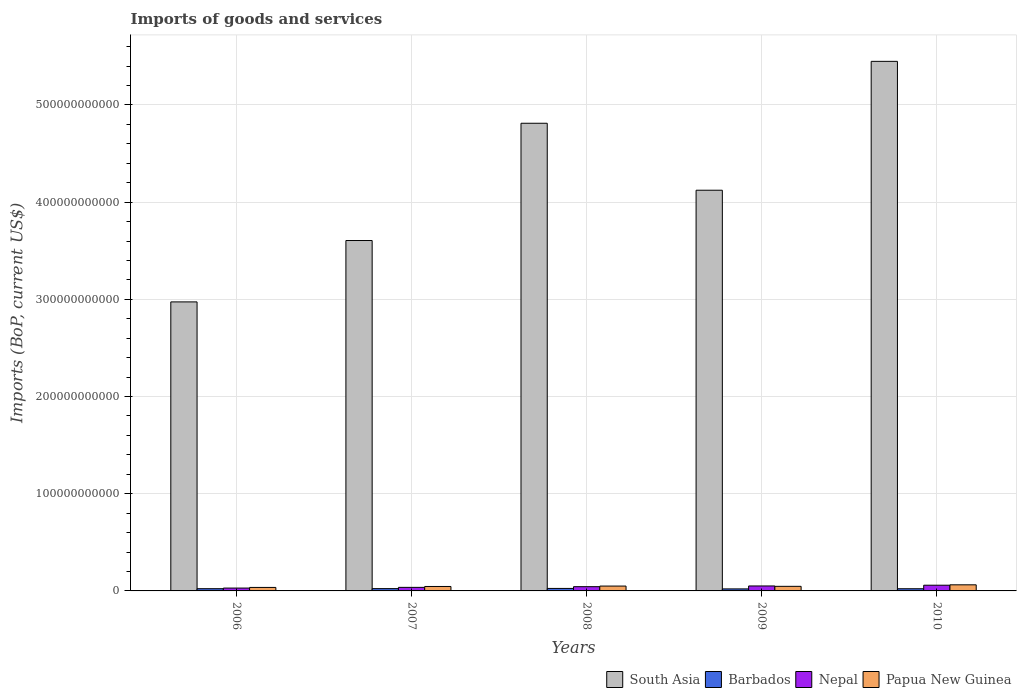How many different coloured bars are there?
Ensure brevity in your answer.  4. Are the number of bars per tick equal to the number of legend labels?
Keep it short and to the point. Yes. Are the number of bars on each tick of the X-axis equal?
Your response must be concise. Yes. How many bars are there on the 4th tick from the left?
Offer a very short reply. 4. How many bars are there on the 2nd tick from the right?
Your answer should be very brief. 4. What is the label of the 2nd group of bars from the left?
Offer a terse response. 2007. In how many cases, is the number of bars for a given year not equal to the number of legend labels?
Give a very brief answer. 0. What is the amount spent on imports in South Asia in 2007?
Your answer should be very brief. 3.61e+11. Across all years, what is the maximum amount spent on imports in Nepal?
Offer a terse response. 5.88e+09. Across all years, what is the minimum amount spent on imports in Barbados?
Offer a terse response. 2.08e+09. In which year was the amount spent on imports in South Asia maximum?
Make the answer very short. 2010. What is the total amount spent on imports in South Asia in the graph?
Make the answer very short. 2.10e+12. What is the difference between the amount spent on imports in Nepal in 2007 and that in 2008?
Make the answer very short. -7.16e+08. What is the difference between the amount spent on imports in South Asia in 2008 and the amount spent on imports in Nepal in 2006?
Provide a short and direct response. 4.78e+11. What is the average amount spent on imports in Papua New Guinea per year?
Ensure brevity in your answer.  4.83e+09. In the year 2006, what is the difference between the amount spent on imports in South Asia and amount spent on imports in Barbados?
Keep it short and to the point. 2.95e+11. In how many years, is the amount spent on imports in South Asia greater than 240000000000 US$?
Give a very brief answer. 5. What is the ratio of the amount spent on imports in Papua New Guinea in 2009 to that in 2010?
Your answer should be compact. 0.75. Is the amount spent on imports in Barbados in 2006 less than that in 2009?
Your response must be concise. No. What is the difference between the highest and the second highest amount spent on imports in South Asia?
Give a very brief answer. 6.37e+1. What is the difference between the highest and the lowest amount spent on imports in Papua New Guinea?
Give a very brief answer. 2.70e+09. In how many years, is the amount spent on imports in Papua New Guinea greater than the average amount spent on imports in Papua New Guinea taken over all years?
Your answer should be compact. 2. Is the sum of the amount spent on imports in Barbados in 2008 and 2010 greater than the maximum amount spent on imports in Papua New Guinea across all years?
Provide a succinct answer. No. Is it the case that in every year, the sum of the amount spent on imports in Papua New Guinea and amount spent on imports in South Asia is greater than the sum of amount spent on imports in Barbados and amount spent on imports in Nepal?
Ensure brevity in your answer.  Yes. What does the 2nd bar from the left in 2007 represents?
Keep it short and to the point. Barbados. What does the 3rd bar from the right in 2006 represents?
Keep it short and to the point. Barbados. Is it the case that in every year, the sum of the amount spent on imports in Papua New Guinea and amount spent on imports in Barbados is greater than the amount spent on imports in South Asia?
Provide a short and direct response. No. Are all the bars in the graph horizontal?
Your answer should be very brief. No. How many years are there in the graph?
Your answer should be very brief. 5. What is the difference between two consecutive major ticks on the Y-axis?
Provide a succinct answer. 1.00e+11. Does the graph contain grids?
Keep it short and to the point. Yes. Where does the legend appear in the graph?
Provide a succinct answer. Bottom right. How many legend labels are there?
Keep it short and to the point. 4. How are the legend labels stacked?
Make the answer very short. Horizontal. What is the title of the graph?
Give a very brief answer. Imports of goods and services. Does "Liechtenstein" appear as one of the legend labels in the graph?
Keep it short and to the point. No. What is the label or title of the Y-axis?
Your response must be concise. Imports (BoP, current US$). What is the Imports (BoP, current US$) of South Asia in 2006?
Your answer should be compact. 2.97e+11. What is the Imports (BoP, current US$) of Barbados in 2006?
Keep it short and to the point. 2.29e+09. What is the Imports (BoP, current US$) in Nepal in 2006?
Give a very brief answer. 2.93e+09. What is the Imports (BoP, current US$) in Papua New Guinea in 2006?
Your response must be concise. 3.59e+09. What is the Imports (BoP, current US$) in South Asia in 2007?
Provide a short and direct response. 3.61e+11. What is the Imports (BoP, current US$) of Barbados in 2007?
Keep it short and to the point. 2.37e+09. What is the Imports (BoP, current US$) of Nepal in 2007?
Offer a very short reply. 3.66e+09. What is the Imports (BoP, current US$) of Papua New Guinea in 2007?
Ensure brevity in your answer.  4.57e+09. What is the Imports (BoP, current US$) in South Asia in 2008?
Provide a succinct answer. 4.81e+11. What is the Imports (BoP, current US$) in Barbados in 2008?
Ensure brevity in your answer.  2.57e+09. What is the Imports (BoP, current US$) of Nepal in 2008?
Make the answer very short. 4.37e+09. What is the Imports (BoP, current US$) of Papua New Guinea in 2008?
Offer a terse response. 4.98e+09. What is the Imports (BoP, current US$) in South Asia in 2009?
Your answer should be very brief. 4.12e+11. What is the Imports (BoP, current US$) of Barbados in 2009?
Ensure brevity in your answer.  2.08e+09. What is the Imports (BoP, current US$) in Nepal in 2009?
Your answer should be compact. 5.10e+09. What is the Imports (BoP, current US$) in Papua New Guinea in 2009?
Offer a terse response. 4.71e+09. What is the Imports (BoP, current US$) of South Asia in 2010?
Offer a very short reply. 5.45e+11. What is the Imports (BoP, current US$) of Barbados in 2010?
Your answer should be compact. 2.24e+09. What is the Imports (BoP, current US$) of Nepal in 2010?
Give a very brief answer. 5.88e+09. What is the Imports (BoP, current US$) of Papua New Guinea in 2010?
Your response must be concise. 6.29e+09. Across all years, what is the maximum Imports (BoP, current US$) of South Asia?
Ensure brevity in your answer.  5.45e+11. Across all years, what is the maximum Imports (BoP, current US$) in Barbados?
Give a very brief answer. 2.57e+09. Across all years, what is the maximum Imports (BoP, current US$) in Nepal?
Make the answer very short. 5.88e+09. Across all years, what is the maximum Imports (BoP, current US$) of Papua New Guinea?
Provide a short and direct response. 6.29e+09. Across all years, what is the minimum Imports (BoP, current US$) of South Asia?
Ensure brevity in your answer.  2.97e+11. Across all years, what is the minimum Imports (BoP, current US$) of Barbados?
Offer a terse response. 2.08e+09. Across all years, what is the minimum Imports (BoP, current US$) in Nepal?
Ensure brevity in your answer.  2.93e+09. Across all years, what is the minimum Imports (BoP, current US$) in Papua New Guinea?
Provide a short and direct response. 3.59e+09. What is the total Imports (BoP, current US$) in South Asia in the graph?
Your response must be concise. 2.10e+12. What is the total Imports (BoP, current US$) in Barbados in the graph?
Ensure brevity in your answer.  1.15e+1. What is the total Imports (BoP, current US$) of Nepal in the graph?
Provide a succinct answer. 2.19e+1. What is the total Imports (BoP, current US$) in Papua New Guinea in the graph?
Ensure brevity in your answer.  2.41e+1. What is the difference between the Imports (BoP, current US$) in South Asia in 2006 and that in 2007?
Your answer should be very brief. -6.32e+1. What is the difference between the Imports (BoP, current US$) of Barbados in 2006 and that in 2007?
Provide a succinct answer. -7.39e+07. What is the difference between the Imports (BoP, current US$) of Nepal in 2006 and that in 2007?
Offer a terse response. -7.21e+08. What is the difference between the Imports (BoP, current US$) of Papua New Guinea in 2006 and that in 2007?
Provide a short and direct response. -9.88e+08. What is the difference between the Imports (BoP, current US$) of South Asia in 2006 and that in 2008?
Ensure brevity in your answer.  -1.84e+11. What is the difference between the Imports (BoP, current US$) of Barbados in 2006 and that in 2008?
Offer a terse response. -2.74e+08. What is the difference between the Imports (BoP, current US$) in Nepal in 2006 and that in 2008?
Provide a succinct answer. -1.44e+09. What is the difference between the Imports (BoP, current US$) of Papua New Guinea in 2006 and that in 2008?
Provide a succinct answer. -1.40e+09. What is the difference between the Imports (BoP, current US$) of South Asia in 2006 and that in 2009?
Offer a very short reply. -1.15e+11. What is the difference between the Imports (BoP, current US$) of Barbados in 2006 and that in 2009?
Give a very brief answer. 2.17e+08. What is the difference between the Imports (BoP, current US$) in Nepal in 2006 and that in 2009?
Give a very brief answer. -2.17e+09. What is the difference between the Imports (BoP, current US$) in Papua New Guinea in 2006 and that in 2009?
Provide a succinct answer. -1.12e+09. What is the difference between the Imports (BoP, current US$) in South Asia in 2006 and that in 2010?
Give a very brief answer. -2.48e+11. What is the difference between the Imports (BoP, current US$) in Barbados in 2006 and that in 2010?
Make the answer very short. 5.40e+07. What is the difference between the Imports (BoP, current US$) in Nepal in 2006 and that in 2010?
Offer a very short reply. -2.94e+09. What is the difference between the Imports (BoP, current US$) in Papua New Guinea in 2006 and that in 2010?
Offer a terse response. -2.70e+09. What is the difference between the Imports (BoP, current US$) in South Asia in 2007 and that in 2008?
Ensure brevity in your answer.  -1.21e+11. What is the difference between the Imports (BoP, current US$) of Barbados in 2007 and that in 2008?
Your response must be concise. -2.00e+08. What is the difference between the Imports (BoP, current US$) in Nepal in 2007 and that in 2008?
Provide a short and direct response. -7.16e+08. What is the difference between the Imports (BoP, current US$) in Papua New Guinea in 2007 and that in 2008?
Keep it short and to the point. -4.09e+08. What is the difference between the Imports (BoP, current US$) in South Asia in 2007 and that in 2009?
Make the answer very short. -5.18e+1. What is the difference between the Imports (BoP, current US$) in Barbados in 2007 and that in 2009?
Ensure brevity in your answer.  2.91e+08. What is the difference between the Imports (BoP, current US$) of Nepal in 2007 and that in 2009?
Provide a short and direct response. -1.45e+09. What is the difference between the Imports (BoP, current US$) in Papua New Guinea in 2007 and that in 2009?
Offer a terse response. -1.36e+08. What is the difference between the Imports (BoP, current US$) in South Asia in 2007 and that in 2010?
Provide a succinct answer. -1.84e+11. What is the difference between the Imports (BoP, current US$) in Barbados in 2007 and that in 2010?
Your response must be concise. 1.28e+08. What is the difference between the Imports (BoP, current US$) of Nepal in 2007 and that in 2010?
Your answer should be very brief. -2.22e+09. What is the difference between the Imports (BoP, current US$) of Papua New Guinea in 2007 and that in 2010?
Keep it short and to the point. -1.71e+09. What is the difference between the Imports (BoP, current US$) of South Asia in 2008 and that in 2009?
Ensure brevity in your answer.  6.89e+1. What is the difference between the Imports (BoP, current US$) in Barbados in 2008 and that in 2009?
Give a very brief answer. 4.92e+08. What is the difference between the Imports (BoP, current US$) in Nepal in 2008 and that in 2009?
Provide a short and direct response. -7.30e+08. What is the difference between the Imports (BoP, current US$) in Papua New Guinea in 2008 and that in 2009?
Provide a short and direct response. 2.73e+08. What is the difference between the Imports (BoP, current US$) in South Asia in 2008 and that in 2010?
Your answer should be compact. -6.37e+1. What is the difference between the Imports (BoP, current US$) of Barbados in 2008 and that in 2010?
Give a very brief answer. 3.28e+08. What is the difference between the Imports (BoP, current US$) in Nepal in 2008 and that in 2010?
Make the answer very short. -1.51e+09. What is the difference between the Imports (BoP, current US$) in Papua New Guinea in 2008 and that in 2010?
Provide a succinct answer. -1.30e+09. What is the difference between the Imports (BoP, current US$) in South Asia in 2009 and that in 2010?
Provide a succinct answer. -1.33e+11. What is the difference between the Imports (BoP, current US$) in Barbados in 2009 and that in 2010?
Your response must be concise. -1.63e+08. What is the difference between the Imports (BoP, current US$) of Nepal in 2009 and that in 2010?
Give a very brief answer. -7.78e+08. What is the difference between the Imports (BoP, current US$) in Papua New Guinea in 2009 and that in 2010?
Your response must be concise. -1.57e+09. What is the difference between the Imports (BoP, current US$) of South Asia in 2006 and the Imports (BoP, current US$) of Barbados in 2007?
Your response must be concise. 2.95e+11. What is the difference between the Imports (BoP, current US$) of South Asia in 2006 and the Imports (BoP, current US$) of Nepal in 2007?
Provide a short and direct response. 2.94e+11. What is the difference between the Imports (BoP, current US$) in South Asia in 2006 and the Imports (BoP, current US$) in Papua New Guinea in 2007?
Make the answer very short. 2.93e+11. What is the difference between the Imports (BoP, current US$) of Barbados in 2006 and the Imports (BoP, current US$) of Nepal in 2007?
Your answer should be very brief. -1.36e+09. What is the difference between the Imports (BoP, current US$) of Barbados in 2006 and the Imports (BoP, current US$) of Papua New Guinea in 2007?
Give a very brief answer. -2.28e+09. What is the difference between the Imports (BoP, current US$) in Nepal in 2006 and the Imports (BoP, current US$) in Papua New Guinea in 2007?
Your response must be concise. -1.64e+09. What is the difference between the Imports (BoP, current US$) in South Asia in 2006 and the Imports (BoP, current US$) in Barbados in 2008?
Ensure brevity in your answer.  2.95e+11. What is the difference between the Imports (BoP, current US$) in South Asia in 2006 and the Imports (BoP, current US$) in Nepal in 2008?
Your response must be concise. 2.93e+11. What is the difference between the Imports (BoP, current US$) of South Asia in 2006 and the Imports (BoP, current US$) of Papua New Guinea in 2008?
Give a very brief answer. 2.92e+11. What is the difference between the Imports (BoP, current US$) of Barbados in 2006 and the Imports (BoP, current US$) of Nepal in 2008?
Offer a very short reply. -2.08e+09. What is the difference between the Imports (BoP, current US$) of Barbados in 2006 and the Imports (BoP, current US$) of Papua New Guinea in 2008?
Provide a succinct answer. -2.69e+09. What is the difference between the Imports (BoP, current US$) of Nepal in 2006 and the Imports (BoP, current US$) of Papua New Guinea in 2008?
Your answer should be compact. -2.05e+09. What is the difference between the Imports (BoP, current US$) in South Asia in 2006 and the Imports (BoP, current US$) in Barbados in 2009?
Your answer should be very brief. 2.95e+11. What is the difference between the Imports (BoP, current US$) in South Asia in 2006 and the Imports (BoP, current US$) in Nepal in 2009?
Your response must be concise. 2.92e+11. What is the difference between the Imports (BoP, current US$) of South Asia in 2006 and the Imports (BoP, current US$) of Papua New Guinea in 2009?
Offer a terse response. 2.93e+11. What is the difference between the Imports (BoP, current US$) in Barbados in 2006 and the Imports (BoP, current US$) in Nepal in 2009?
Your response must be concise. -2.81e+09. What is the difference between the Imports (BoP, current US$) of Barbados in 2006 and the Imports (BoP, current US$) of Papua New Guinea in 2009?
Keep it short and to the point. -2.42e+09. What is the difference between the Imports (BoP, current US$) in Nepal in 2006 and the Imports (BoP, current US$) in Papua New Guinea in 2009?
Your response must be concise. -1.78e+09. What is the difference between the Imports (BoP, current US$) in South Asia in 2006 and the Imports (BoP, current US$) in Barbados in 2010?
Give a very brief answer. 2.95e+11. What is the difference between the Imports (BoP, current US$) of South Asia in 2006 and the Imports (BoP, current US$) of Nepal in 2010?
Provide a short and direct response. 2.92e+11. What is the difference between the Imports (BoP, current US$) of South Asia in 2006 and the Imports (BoP, current US$) of Papua New Guinea in 2010?
Your response must be concise. 2.91e+11. What is the difference between the Imports (BoP, current US$) of Barbados in 2006 and the Imports (BoP, current US$) of Nepal in 2010?
Your answer should be very brief. -3.58e+09. What is the difference between the Imports (BoP, current US$) of Barbados in 2006 and the Imports (BoP, current US$) of Papua New Guinea in 2010?
Your answer should be very brief. -3.99e+09. What is the difference between the Imports (BoP, current US$) of Nepal in 2006 and the Imports (BoP, current US$) of Papua New Guinea in 2010?
Provide a short and direct response. -3.35e+09. What is the difference between the Imports (BoP, current US$) of South Asia in 2007 and the Imports (BoP, current US$) of Barbados in 2008?
Make the answer very short. 3.58e+11. What is the difference between the Imports (BoP, current US$) in South Asia in 2007 and the Imports (BoP, current US$) in Nepal in 2008?
Your answer should be very brief. 3.56e+11. What is the difference between the Imports (BoP, current US$) of South Asia in 2007 and the Imports (BoP, current US$) of Papua New Guinea in 2008?
Make the answer very short. 3.56e+11. What is the difference between the Imports (BoP, current US$) in Barbados in 2007 and the Imports (BoP, current US$) in Nepal in 2008?
Make the answer very short. -2.00e+09. What is the difference between the Imports (BoP, current US$) of Barbados in 2007 and the Imports (BoP, current US$) of Papua New Guinea in 2008?
Provide a succinct answer. -2.62e+09. What is the difference between the Imports (BoP, current US$) in Nepal in 2007 and the Imports (BoP, current US$) in Papua New Guinea in 2008?
Make the answer very short. -1.33e+09. What is the difference between the Imports (BoP, current US$) in South Asia in 2007 and the Imports (BoP, current US$) in Barbados in 2009?
Keep it short and to the point. 3.58e+11. What is the difference between the Imports (BoP, current US$) in South Asia in 2007 and the Imports (BoP, current US$) in Nepal in 2009?
Your answer should be very brief. 3.55e+11. What is the difference between the Imports (BoP, current US$) in South Asia in 2007 and the Imports (BoP, current US$) in Papua New Guinea in 2009?
Offer a terse response. 3.56e+11. What is the difference between the Imports (BoP, current US$) in Barbados in 2007 and the Imports (BoP, current US$) in Nepal in 2009?
Provide a short and direct response. -2.73e+09. What is the difference between the Imports (BoP, current US$) in Barbados in 2007 and the Imports (BoP, current US$) in Papua New Guinea in 2009?
Provide a succinct answer. -2.34e+09. What is the difference between the Imports (BoP, current US$) of Nepal in 2007 and the Imports (BoP, current US$) of Papua New Guinea in 2009?
Offer a terse response. -1.06e+09. What is the difference between the Imports (BoP, current US$) of South Asia in 2007 and the Imports (BoP, current US$) of Barbados in 2010?
Give a very brief answer. 3.58e+11. What is the difference between the Imports (BoP, current US$) of South Asia in 2007 and the Imports (BoP, current US$) of Nepal in 2010?
Your answer should be compact. 3.55e+11. What is the difference between the Imports (BoP, current US$) in South Asia in 2007 and the Imports (BoP, current US$) in Papua New Guinea in 2010?
Offer a terse response. 3.54e+11. What is the difference between the Imports (BoP, current US$) in Barbados in 2007 and the Imports (BoP, current US$) in Nepal in 2010?
Make the answer very short. -3.51e+09. What is the difference between the Imports (BoP, current US$) of Barbados in 2007 and the Imports (BoP, current US$) of Papua New Guinea in 2010?
Keep it short and to the point. -3.92e+09. What is the difference between the Imports (BoP, current US$) in Nepal in 2007 and the Imports (BoP, current US$) in Papua New Guinea in 2010?
Offer a terse response. -2.63e+09. What is the difference between the Imports (BoP, current US$) in South Asia in 2008 and the Imports (BoP, current US$) in Barbados in 2009?
Offer a terse response. 4.79e+11. What is the difference between the Imports (BoP, current US$) in South Asia in 2008 and the Imports (BoP, current US$) in Nepal in 2009?
Give a very brief answer. 4.76e+11. What is the difference between the Imports (BoP, current US$) of South Asia in 2008 and the Imports (BoP, current US$) of Papua New Guinea in 2009?
Provide a succinct answer. 4.77e+11. What is the difference between the Imports (BoP, current US$) in Barbados in 2008 and the Imports (BoP, current US$) in Nepal in 2009?
Offer a terse response. -2.53e+09. What is the difference between the Imports (BoP, current US$) in Barbados in 2008 and the Imports (BoP, current US$) in Papua New Guinea in 2009?
Ensure brevity in your answer.  -2.14e+09. What is the difference between the Imports (BoP, current US$) in Nepal in 2008 and the Imports (BoP, current US$) in Papua New Guinea in 2009?
Offer a terse response. -3.40e+08. What is the difference between the Imports (BoP, current US$) of South Asia in 2008 and the Imports (BoP, current US$) of Barbados in 2010?
Make the answer very short. 4.79e+11. What is the difference between the Imports (BoP, current US$) in South Asia in 2008 and the Imports (BoP, current US$) in Nepal in 2010?
Your response must be concise. 4.75e+11. What is the difference between the Imports (BoP, current US$) in South Asia in 2008 and the Imports (BoP, current US$) in Papua New Guinea in 2010?
Offer a very short reply. 4.75e+11. What is the difference between the Imports (BoP, current US$) of Barbados in 2008 and the Imports (BoP, current US$) of Nepal in 2010?
Ensure brevity in your answer.  -3.31e+09. What is the difference between the Imports (BoP, current US$) in Barbados in 2008 and the Imports (BoP, current US$) in Papua New Guinea in 2010?
Offer a very short reply. -3.72e+09. What is the difference between the Imports (BoP, current US$) in Nepal in 2008 and the Imports (BoP, current US$) in Papua New Guinea in 2010?
Provide a short and direct response. -1.91e+09. What is the difference between the Imports (BoP, current US$) of South Asia in 2009 and the Imports (BoP, current US$) of Barbados in 2010?
Provide a succinct answer. 4.10e+11. What is the difference between the Imports (BoP, current US$) in South Asia in 2009 and the Imports (BoP, current US$) in Nepal in 2010?
Provide a succinct answer. 4.06e+11. What is the difference between the Imports (BoP, current US$) of South Asia in 2009 and the Imports (BoP, current US$) of Papua New Guinea in 2010?
Ensure brevity in your answer.  4.06e+11. What is the difference between the Imports (BoP, current US$) of Barbados in 2009 and the Imports (BoP, current US$) of Nepal in 2010?
Ensure brevity in your answer.  -3.80e+09. What is the difference between the Imports (BoP, current US$) in Barbados in 2009 and the Imports (BoP, current US$) in Papua New Guinea in 2010?
Your answer should be very brief. -4.21e+09. What is the difference between the Imports (BoP, current US$) in Nepal in 2009 and the Imports (BoP, current US$) in Papua New Guinea in 2010?
Your response must be concise. -1.18e+09. What is the average Imports (BoP, current US$) of South Asia per year?
Your answer should be very brief. 4.19e+11. What is the average Imports (BoP, current US$) in Barbados per year?
Your answer should be very brief. 2.31e+09. What is the average Imports (BoP, current US$) in Nepal per year?
Your response must be concise. 4.39e+09. What is the average Imports (BoP, current US$) of Papua New Guinea per year?
Provide a short and direct response. 4.83e+09. In the year 2006, what is the difference between the Imports (BoP, current US$) of South Asia and Imports (BoP, current US$) of Barbados?
Keep it short and to the point. 2.95e+11. In the year 2006, what is the difference between the Imports (BoP, current US$) of South Asia and Imports (BoP, current US$) of Nepal?
Give a very brief answer. 2.94e+11. In the year 2006, what is the difference between the Imports (BoP, current US$) of South Asia and Imports (BoP, current US$) of Papua New Guinea?
Ensure brevity in your answer.  2.94e+11. In the year 2006, what is the difference between the Imports (BoP, current US$) in Barbados and Imports (BoP, current US$) in Nepal?
Your response must be concise. -6.39e+08. In the year 2006, what is the difference between the Imports (BoP, current US$) in Barbados and Imports (BoP, current US$) in Papua New Guinea?
Your answer should be compact. -1.29e+09. In the year 2006, what is the difference between the Imports (BoP, current US$) of Nepal and Imports (BoP, current US$) of Papua New Guinea?
Your answer should be compact. -6.52e+08. In the year 2007, what is the difference between the Imports (BoP, current US$) in South Asia and Imports (BoP, current US$) in Barbados?
Provide a short and direct response. 3.58e+11. In the year 2007, what is the difference between the Imports (BoP, current US$) in South Asia and Imports (BoP, current US$) in Nepal?
Offer a terse response. 3.57e+11. In the year 2007, what is the difference between the Imports (BoP, current US$) in South Asia and Imports (BoP, current US$) in Papua New Guinea?
Ensure brevity in your answer.  3.56e+11. In the year 2007, what is the difference between the Imports (BoP, current US$) of Barbados and Imports (BoP, current US$) of Nepal?
Ensure brevity in your answer.  -1.29e+09. In the year 2007, what is the difference between the Imports (BoP, current US$) in Barbados and Imports (BoP, current US$) in Papua New Guinea?
Provide a succinct answer. -2.21e+09. In the year 2007, what is the difference between the Imports (BoP, current US$) in Nepal and Imports (BoP, current US$) in Papua New Guinea?
Provide a short and direct response. -9.19e+08. In the year 2008, what is the difference between the Imports (BoP, current US$) in South Asia and Imports (BoP, current US$) in Barbados?
Provide a short and direct response. 4.79e+11. In the year 2008, what is the difference between the Imports (BoP, current US$) in South Asia and Imports (BoP, current US$) in Nepal?
Offer a terse response. 4.77e+11. In the year 2008, what is the difference between the Imports (BoP, current US$) of South Asia and Imports (BoP, current US$) of Papua New Guinea?
Your answer should be compact. 4.76e+11. In the year 2008, what is the difference between the Imports (BoP, current US$) of Barbados and Imports (BoP, current US$) of Nepal?
Your response must be concise. -1.80e+09. In the year 2008, what is the difference between the Imports (BoP, current US$) in Barbados and Imports (BoP, current US$) in Papua New Guinea?
Provide a short and direct response. -2.42e+09. In the year 2008, what is the difference between the Imports (BoP, current US$) in Nepal and Imports (BoP, current US$) in Papua New Guinea?
Your response must be concise. -6.12e+08. In the year 2009, what is the difference between the Imports (BoP, current US$) in South Asia and Imports (BoP, current US$) in Barbados?
Provide a short and direct response. 4.10e+11. In the year 2009, what is the difference between the Imports (BoP, current US$) in South Asia and Imports (BoP, current US$) in Nepal?
Provide a succinct answer. 4.07e+11. In the year 2009, what is the difference between the Imports (BoP, current US$) of South Asia and Imports (BoP, current US$) of Papua New Guinea?
Offer a very short reply. 4.08e+11. In the year 2009, what is the difference between the Imports (BoP, current US$) of Barbados and Imports (BoP, current US$) of Nepal?
Your response must be concise. -3.02e+09. In the year 2009, what is the difference between the Imports (BoP, current US$) in Barbados and Imports (BoP, current US$) in Papua New Guinea?
Your answer should be compact. -2.63e+09. In the year 2009, what is the difference between the Imports (BoP, current US$) of Nepal and Imports (BoP, current US$) of Papua New Guinea?
Provide a succinct answer. 3.90e+08. In the year 2010, what is the difference between the Imports (BoP, current US$) of South Asia and Imports (BoP, current US$) of Barbados?
Offer a very short reply. 5.43e+11. In the year 2010, what is the difference between the Imports (BoP, current US$) of South Asia and Imports (BoP, current US$) of Nepal?
Ensure brevity in your answer.  5.39e+11. In the year 2010, what is the difference between the Imports (BoP, current US$) of South Asia and Imports (BoP, current US$) of Papua New Guinea?
Give a very brief answer. 5.39e+11. In the year 2010, what is the difference between the Imports (BoP, current US$) in Barbados and Imports (BoP, current US$) in Nepal?
Give a very brief answer. -3.64e+09. In the year 2010, what is the difference between the Imports (BoP, current US$) in Barbados and Imports (BoP, current US$) in Papua New Guinea?
Offer a very short reply. -4.05e+09. In the year 2010, what is the difference between the Imports (BoP, current US$) in Nepal and Imports (BoP, current US$) in Papua New Guinea?
Your answer should be compact. -4.07e+08. What is the ratio of the Imports (BoP, current US$) of South Asia in 2006 to that in 2007?
Offer a terse response. 0.82. What is the ratio of the Imports (BoP, current US$) in Barbados in 2006 to that in 2007?
Provide a short and direct response. 0.97. What is the ratio of the Imports (BoP, current US$) in Nepal in 2006 to that in 2007?
Your answer should be compact. 0.8. What is the ratio of the Imports (BoP, current US$) of Papua New Guinea in 2006 to that in 2007?
Your answer should be very brief. 0.78. What is the ratio of the Imports (BoP, current US$) of South Asia in 2006 to that in 2008?
Ensure brevity in your answer.  0.62. What is the ratio of the Imports (BoP, current US$) of Barbados in 2006 to that in 2008?
Your answer should be compact. 0.89. What is the ratio of the Imports (BoP, current US$) in Nepal in 2006 to that in 2008?
Your answer should be compact. 0.67. What is the ratio of the Imports (BoP, current US$) of Papua New Guinea in 2006 to that in 2008?
Your answer should be very brief. 0.72. What is the ratio of the Imports (BoP, current US$) of South Asia in 2006 to that in 2009?
Provide a short and direct response. 0.72. What is the ratio of the Imports (BoP, current US$) of Barbados in 2006 to that in 2009?
Your answer should be compact. 1.1. What is the ratio of the Imports (BoP, current US$) in Nepal in 2006 to that in 2009?
Your response must be concise. 0.58. What is the ratio of the Imports (BoP, current US$) in Papua New Guinea in 2006 to that in 2009?
Ensure brevity in your answer.  0.76. What is the ratio of the Imports (BoP, current US$) in South Asia in 2006 to that in 2010?
Your response must be concise. 0.55. What is the ratio of the Imports (BoP, current US$) of Barbados in 2006 to that in 2010?
Ensure brevity in your answer.  1.02. What is the ratio of the Imports (BoP, current US$) of Nepal in 2006 to that in 2010?
Your answer should be very brief. 0.5. What is the ratio of the Imports (BoP, current US$) of Papua New Guinea in 2006 to that in 2010?
Provide a short and direct response. 0.57. What is the ratio of the Imports (BoP, current US$) in South Asia in 2007 to that in 2008?
Provide a short and direct response. 0.75. What is the ratio of the Imports (BoP, current US$) in Barbados in 2007 to that in 2008?
Keep it short and to the point. 0.92. What is the ratio of the Imports (BoP, current US$) of Nepal in 2007 to that in 2008?
Offer a very short reply. 0.84. What is the ratio of the Imports (BoP, current US$) of Papua New Guinea in 2007 to that in 2008?
Ensure brevity in your answer.  0.92. What is the ratio of the Imports (BoP, current US$) of South Asia in 2007 to that in 2009?
Your response must be concise. 0.87. What is the ratio of the Imports (BoP, current US$) of Barbados in 2007 to that in 2009?
Ensure brevity in your answer.  1.14. What is the ratio of the Imports (BoP, current US$) of Nepal in 2007 to that in 2009?
Your answer should be compact. 0.72. What is the ratio of the Imports (BoP, current US$) in Papua New Guinea in 2007 to that in 2009?
Give a very brief answer. 0.97. What is the ratio of the Imports (BoP, current US$) in South Asia in 2007 to that in 2010?
Provide a succinct answer. 0.66. What is the ratio of the Imports (BoP, current US$) of Barbados in 2007 to that in 2010?
Give a very brief answer. 1.06. What is the ratio of the Imports (BoP, current US$) in Nepal in 2007 to that in 2010?
Provide a succinct answer. 0.62. What is the ratio of the Imports (BoP, current US$) of Papua New Guinea in 2007 to that in 2010?
Provide a short and direct response. 0.73. What is the ratio of the Imports (BoP, current US$) of South Asia in 2008 to that in 2009?
Your response must be concise. 1.17. What is the ratio of the Imports (BoP, current US$) in Barbados in 2008 to that in 2009?
Make the answer very short. 1.24. What is the ratio of the Imports (BoP, current US$) of Nepal in 2008 to that in 2009?
Your answer should be compact. 0.86. What is the ratio of the Imports (BoP, current US$) in Papua New Guinea in 2008 to that in 2009?
Provide a short and direct response. 1.06. What is the ratio of the Imports (BoP, current US$) of South Asia in 2008 to that in 2010?
Keep it short and to the point. 0.88. What is the ratio of the Imports (BoP, current US$) of Barbados in 2008 to that in 2010?
Provide a short and direct response. 1.15. What is the ratio of the Imports (BoP, current US$) of Nepal in 2008 to that in 2010?
Offer a terse response. 0.74. What is the ratio of the Imports (BoP, current US$) in Papua New Guinea in 2008 to that in 2010?
Your answer should be very brief. 0.79. What is the ratio of the Imports (BoP, current US$) in South Asia in 2009 to that in 2010?
Your answer should be very brief. 0.76. What is the ratio of the Imports (BoP, current US$) of Barbados in 2009 to that in 2010?
Give a very brief answer. 0.93. What is the ratio of the Imports (BoP, current US$) of Nepal in 2009 to that in 2010?
Provide a succinct answer. 0.87. What is the ratio of the Imports (BoP, current US$) in Papua New Guinea in 2009 to that in 2010?
Ensure brevity in your answer.  0.75. What is the difference between the highest and the second highest Imports (BoP, current US$) of South Asia?
Offer a terse response. 6.37e+1. What is the difference between the highest and the second highest Imports (BoP, current US$) of Barbados?
Your response must be concise. 2.00e+08. What is the difference between the highest and the second highest Imports (BoP, current US$) in Nepal?
Your answer should be compact. 7.78e+08. What is the difference between the highest and the second highest Imports (BoP, current US$) of Papua New Guinea?
Keep it short and to the point. 1.30e+09. What is the difference between the highest and the lowest Imports (BoP, current US$) of South Asia?
Make the answer very short. 2.48e+11. What is the difference between the highest and the lowest Imports (BoP, current US$) in Barbados?
Make the answer very short. 4.92e+08. What is the difference between the highest and the lowest Imports (BoP, current US$) of Nepal?
Keep it short and to the point. 2.94e+09. What is the difference between the highest and the lowest Imports (BoP, current US$) of Papua New Guinea?
Ensure brevity in your answer.  2.70e+09. 